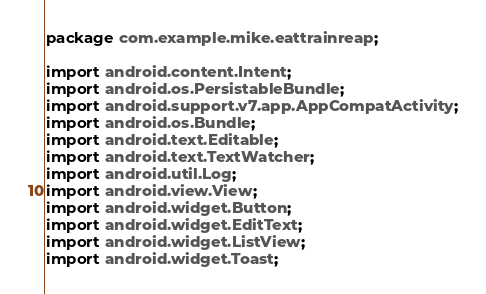<code> <loc_0><loc_0><loc_500><loc_500><_Java_>package com.example.mike.eattrainreap;

import android.content.Intent;
import android.os.PersistableBundle;
import android.support.v7.app.AppCompatActivity;
import android.os.Bundle;
import android.text.Editable;
import android.text.TextWatcher;
import android.util.Log;
import android.view.View;
import android.widget.Button;
import android.widget.EditText;
import android.widget.ListView;
import android.widget.Toast;</code> 